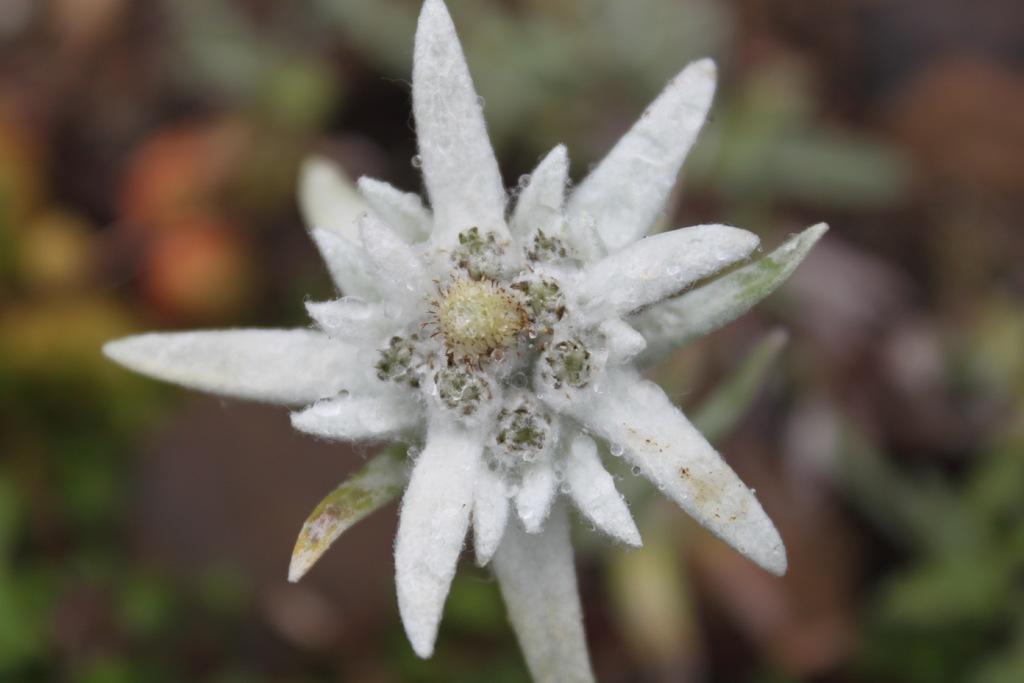Describe this image in one or two sentences. In this image we can see a flower. In the background it is blur. 